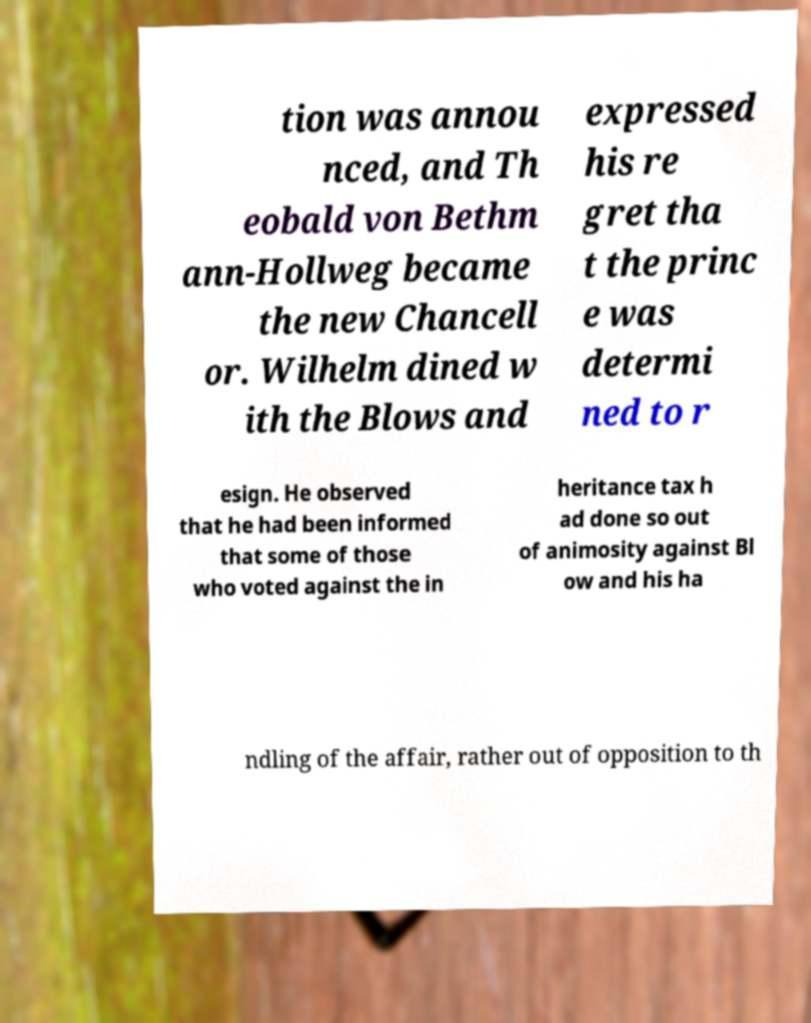Can you read and provide the text displayed in the image?This photo seems to have some interesting text. Can you extract and type it out for me? tion was annou nced, and Th eobald von Bethm ann-Hollweg became the new Chancell or. Wilhelm dined w ith the Blows and expressed his re gret tha t the princ e was determi ned to r esign. He observed that he had been informed that some of those who voted against the in heritance tax h ad done so out of animosity against Bl ow and his ha ndling of the affair, rather out of opposition to th 